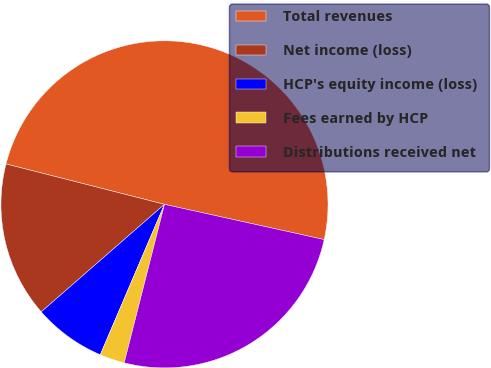<chart> <loc_0><loc_0><loc_500><loc_500><pie_chart><fcel>Total revenues<fcel>Net income (loss)<fcel>HCP's equity income (loss)<fcel>Fees earned by HCP<fcel>Distributions received net<nl><fcel>49.49%<fcel>15.39%<fcel>7.16%<fcel>2.46%<fcel>25.51%<nl></chart> 